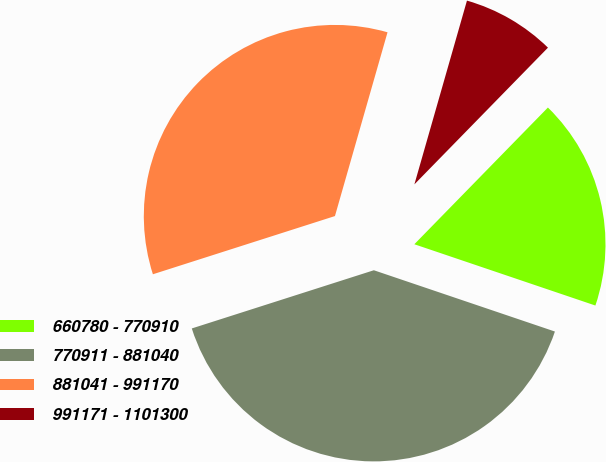<chart> <loc_0><loc_0><loc_500><loc_500><pie_chart><fcel>660780 - 770910<fcel>770911 - 881040<fcel>881041 - 991170<fcel>991171 - 1101300<nl><fcel>17.88%<fcel>39.88%<fcel>34.36%<fcel>7.88%<nl></chart> 